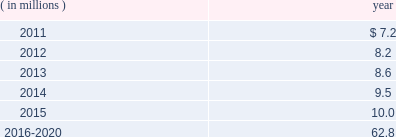The company expects to amortize $ 1.7 million of actuarial loss from accumulated other comprehensive income ( loss ) into net periodic benefit costs in 2011 .
At december 31 , 2010 , anticipated benefit payments from the plan in future years are as follows: .
Savings plans .
Cme maintains a defined contribution savings plan pursuant to section 401 ( k ) of the internal revenue code , whereby all u.s .
Employees are participants and have the option to contribute to this plan .
Cme matches employee contributions up to 3% ( 3 % ) of the employee 2019s base salary and may make additional discretionary contributions of up to 2% ( 2 % ) of base salary .
In addition , certain cme london-based employees are eligible to participate in a defined contribution plan .
For cme london-based employees , the plan provides for company contributions of 10% ( 10 % ) of earnings and does not have any vesting requirements .
Salary and cash bonuses paid are included in the definition of earnings .
Aggregate expense for all of the defined contribution savings plans amounted to $ 6.3 million , $ 5.2 million and $ 5.8 million in 2010 , 2009 and 2008 , respectively .
Cme non-qualified plans .
Cme maintains non-qualified plans , under which participants may make assumed investment choices with respect to amounts contributed on their behalf .
Although not required to do so , cme invests such contributions in assets that mirror the assumed investment choices .
The balances in these plans are subject to the claims of general creditors of the exchange and totaled $ 28.8 million and $ 23.4 million at december 31 , 2010 and 2009 , respectively .
Although the value of the plans is recorded as an asset in the consolidated balance sheets , there is an equal and offsetting liability .
The investment results of these plans have no impact on net income as the investment results are recorded in equal amounts to both investment income and compensation and benefits expense .
Supplemental savings plan 2014cme maintains a supplemental plan to provide benefits for employees who have been impacted by statutory limits under the provisions of the qualified pension and savings plan .
All cme employees hired prior to january 1 , 2007 are immediately vested in their supplemental plan benefits .
All cme employees hired on or after january 1 , 2007 are subject to the vesting requirements of the underlying qualified plans .
Total expense for the supplemental plan was $ 0.9 million , $ 0.7 million and $ 1.3 million for 2010 , 2009 and 2008 , respectively .
Deferred compensation plan 2014a deferred compensation plan is maintained by cme , under which eligible officers and members of the board of directors may contribute a percentage of their compensation and defer income taxes thereon until the time of distribution .
Nymexmembers 2019 retirement plan and benefits .
Nymex maintained a retirement and benefit plan under the commodities exchange , inc .
( comex ) members 2019 recognition and retention plan ( mrrp ) .
This plan provides benefits to certain members of the comex division based on long-term membership , and participation is limited to individuals who were comex division members prior to nymex 2019s acquisition of comex in 1994 .
No new participants were permitted into the plan after the date of this acquisition .
Under the terms of the mrrp , the company is required to fund the plan with a minimum annual contribution of $ 0.4 million until it is fully funded .
All benefits to be paid under the mrrp are based on reasonable actuarial assumptions which are based upon the amounts that are available and are expected to be available to pay benefits .
Total contributions to the plan were $ 0.8 million for each of 2010 , 2009 and for the period august 23 through december 31 , 2008 .
At december 31 , 2010 and 2009 , the total obligation for the mrrp totaled $ 20.7 million and $ 20.5 million .
What was the average of the total amount of expense for all of the defined contribution savings plans during the years 2016-2020 , in millions? 
Rationale: its the total value ( $ 62.8 ) divided by the period of years 2016-2020 ( 5 )
Computations: (62.8 / 5)
Answer: 12.56. 